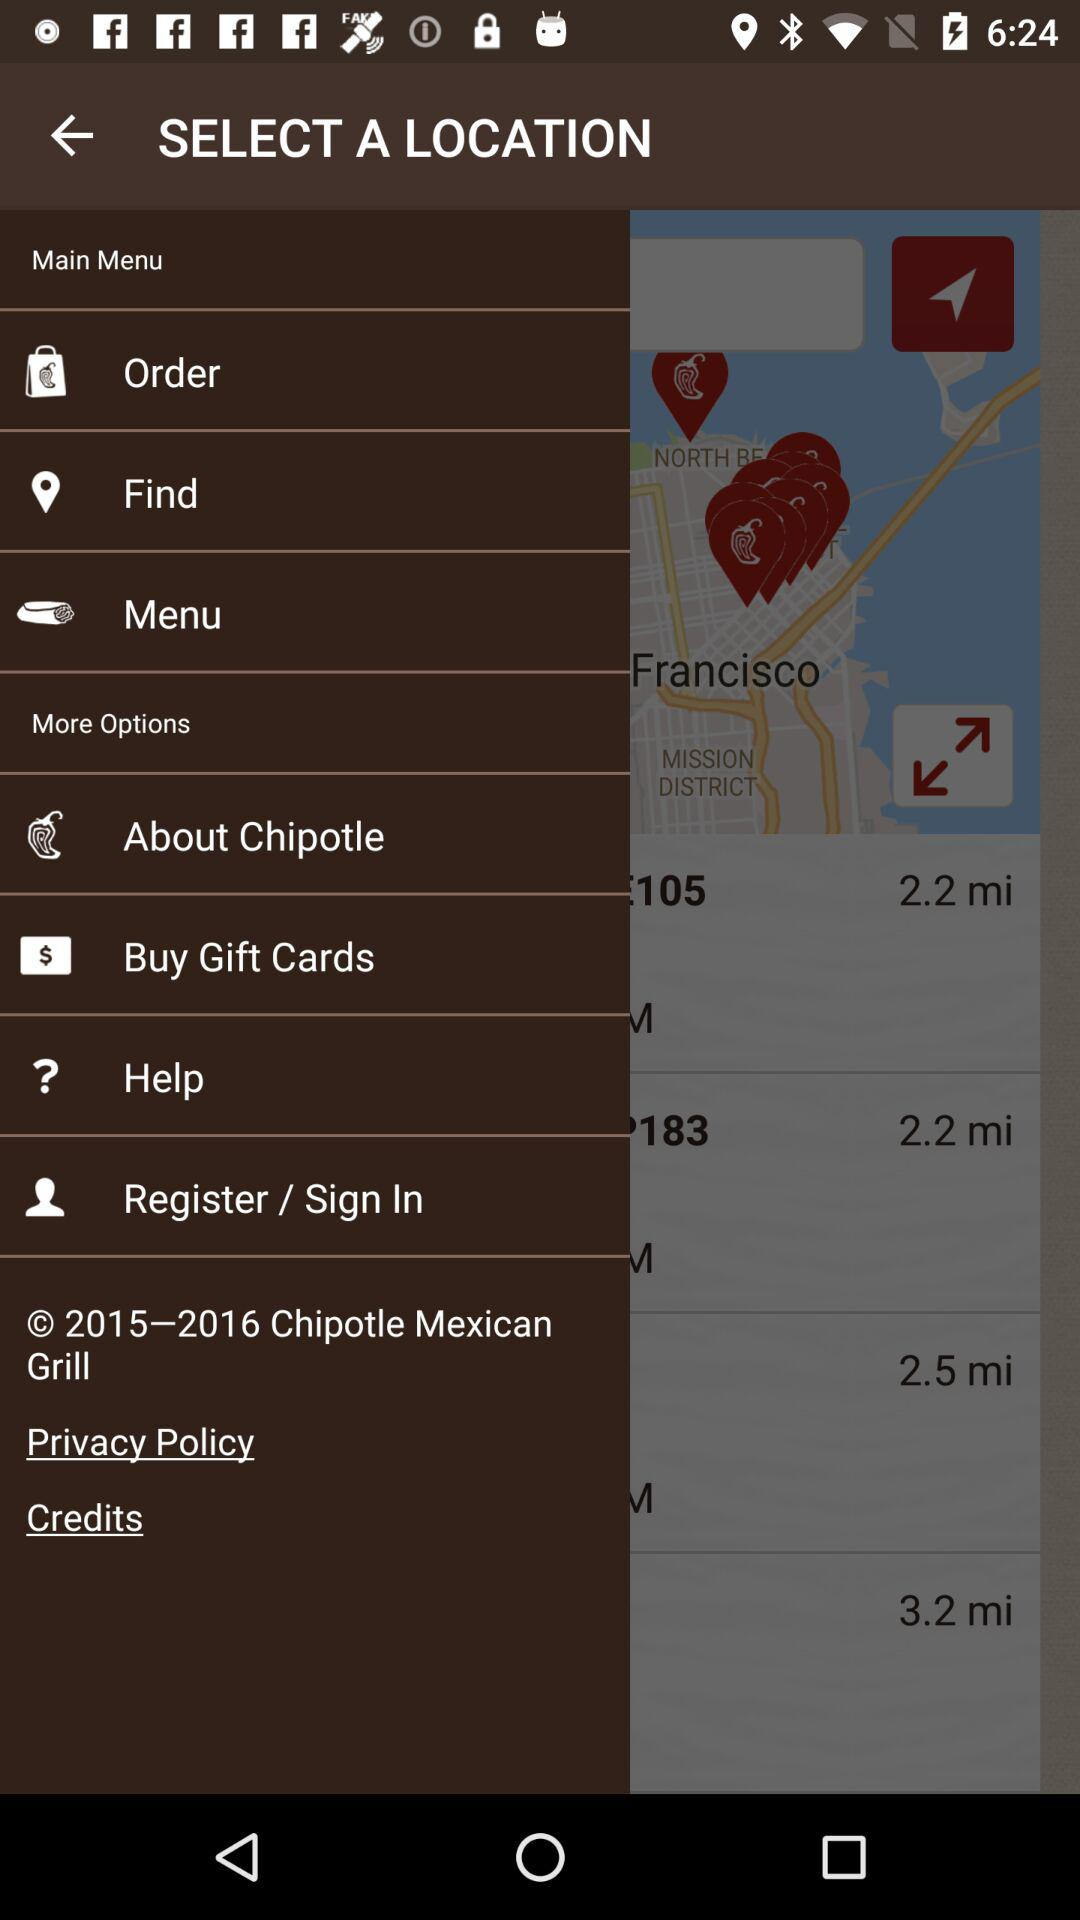How many miles away is the closest location?
Answer the question using a single word or phrase. 2.2 mi 